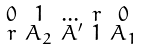<formula> <loc_0><loc_0><loc_500><loc_500>\begin{smallmatrix} 0 & 1 & \dots & r & 0 \\ r & A _ { 2 } & A ^ { \prime } & 1 & A _ { 1 } \end{smallmatrix}</formula> 